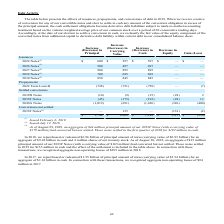According to Micron Technology's financial document, How much principal amount of notes did the company repurchased or redeemed in 2018? According to the financial document, $6.96 billion. The relevant text states: "In 2018, we repurchased or redeemed $6.96 billion of principal amount of notes (carrying value of $6.93 billion) for an..." Also, What was the difference in its carrying value of the issuance of 2027 Notes? According to the financial document, 895. The relevant text states: "2027 Notes (2) 900 895 895 — —..." Also, What was the decrease in equity of settled conversions in 2032D Notes? According to the financial document, (28). The relevant text states: "2032D Notes (10) (9) (35) (28) 2..." Also, can you calculate: What was the total value of the changes in principal on the issuance of 2024 Notes, 2026 Notes, 2027 Notes, 2029 Notes, and 2030 Notes? Based on the calculation: 600+500+900+700+850, the result is 3550. This is based on the information: "2030 Notes (2) 850 845 845 — — 2024 Notes (1) $ 600 $ 597 $ 597 $ — $ — 2026 Notes (1) 500 497 497 — — 2029 Notes (1) 700 695 695 — — 2027 Notes (2) 900 895 895 — —..." The key data points involved are: 500, 600, 700. Also, can you calculate: What is the ratio of the increase in carrying value of 2029 Notes to 2030 Notes? Based on the calculation: 695/845 , the result is 0.82. This is based on the information: "2029 Notes (1) 700 695 695 — — 2030 Notes (2) 850 845 845 — —..." The key data points involved are: 695, 845. Also, can you calculate: What is the difference of increase in cash between 2024 Notes and 2026 Notes? Based on the calculation: 597 - 497 , the result is 100. This is based on the information: "2026 Notes (1) 500 497 497 — — 2024 Notes (1) $ 600 $ 597 $ 597 $ — $ —..." The key data points involved are: 497, 597. 